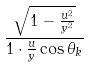Convert formula to latex. <formula><loc_0><loc_0><loc_500><loc_500>\frac { \sqrt { 1 - \frac { u ^ { 2 } } { y ^ { 2 } } } } { 1 \cdot \frac { u } { y } \cos \theta _ { k } }</formula> 